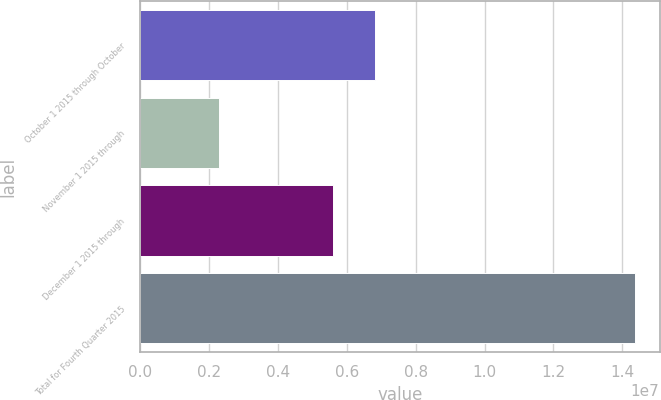Convert chart. <chart><loc_0><loc_0><loc_500><loc_500><bar_chart><fcel>October 1 2015 through October<fcel>November 1 2015 through<fcel>December 1 2015 through<fcel>Total for Fourth Quarter 2015<nl><fcel>6.81715e+06<fcel>2.28352e+06<fcel>5.6093e+06<fcel>1.43619e+07<nl></chart> 